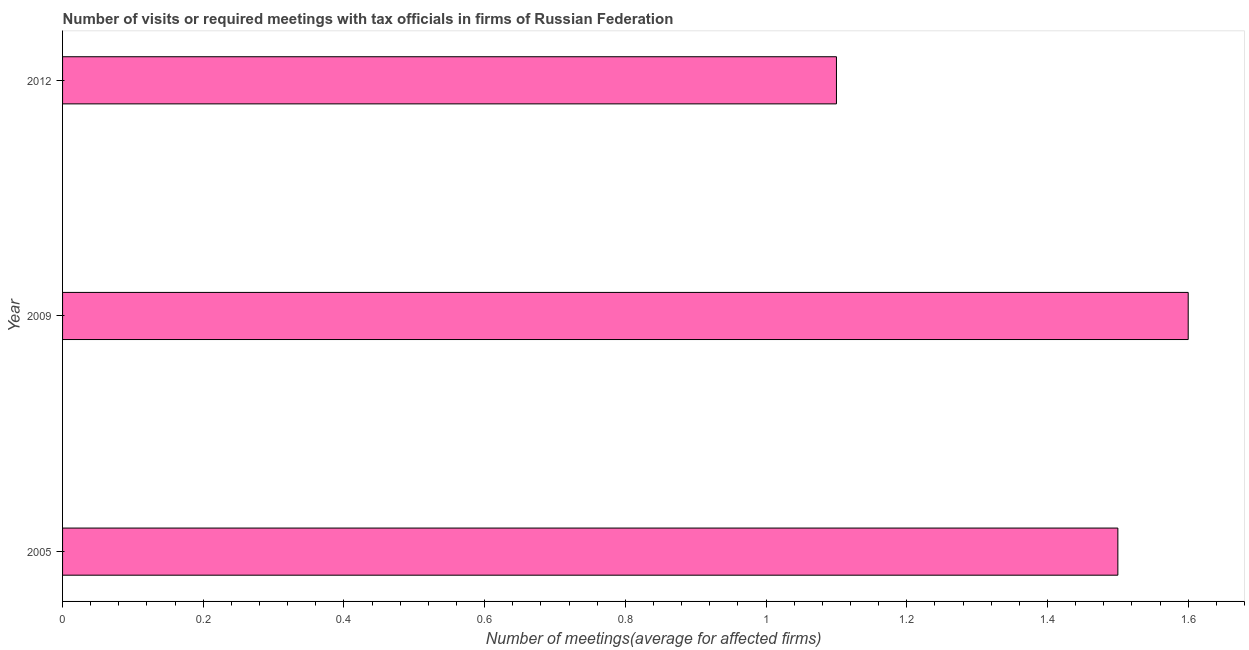Does the graph contain grids?
Your response must be concise. No. What is the title of the graph?
Your answer should be compact. Number of visits or required meetings with tax officials in firms of Russian Federation. What is the label or title of the X-axis?
Offer a terse response. Number of meetings(average for affected firms). What is the label or title of the Y-axis?
Provide a succinct answer. Year. Across all years, what is the maximum number of required meetings with tax officials?
Provide a short and direct response. 1.6. Across all years, what is the minimum number of required meetings with tax officials?
Provide a succinct answer. 1.1. What is the difference between the number of required meetings with tax officials in 2005 and 2009?
Keep it short and to the point. -0.1. What is the average number of required meetings with tax officials per year?
Provide a succinct answer. 1.4. What is the median number of required meetings with tax officials?
Your answer should be very brief. 1.5. In how many years, is the number of required meetings with tax officials greater than 0.32 ?
Make the answer very short. 3. Do a majority of the years between 2009 and 2005 (inclusive) have number of required meetings with tax officials greater than 1.52 ?
Keep it short and to the point. No. What is the ratio of the number of required meetings with tax officials in 2005 to that in 2009?
Make the answer very short. 0.94. Is the number of required meetings with tax officials in 2005 less than that in 2009?
Ensure brevity in your answer.  Yes. What is the difference between the highest and the second highest number of required meetings with tax officials?
Your answer should be compact. 0.1. What is the difference between the highest and the lowest number of required meetings with tax officials?
Your answer should be very brief. 0.5. How many bars are there?
Offer a terse response. 3. What is the difference between two consecutive major ticks on the X-axis?
Give a very brief answer. 0.2. Are the values on the major ticks of X-axis written in scientific E-notation?
Your response must be concise. No. What is the Number of meetings(average for affected firms) of 2005?
Keep it short and to the point. 1.5. What is the Number of meetings(average for affected firms) of 2012?
Keep it short and to the point. 1.1. What is the ratio of the Number of meetings(average for affected firms) in 2005 to that in 2009?
Provide a succinct answer. 0.94. What is the ratio of the Number of meetings(average for affected firms) in 2005 to that in 2012?
Provide a succinct answer. 1.36. What is the ratio of the Number of meetings(average for affected firms) in 2009 to that in 2012?
Offer a very short reply. 1.46. 